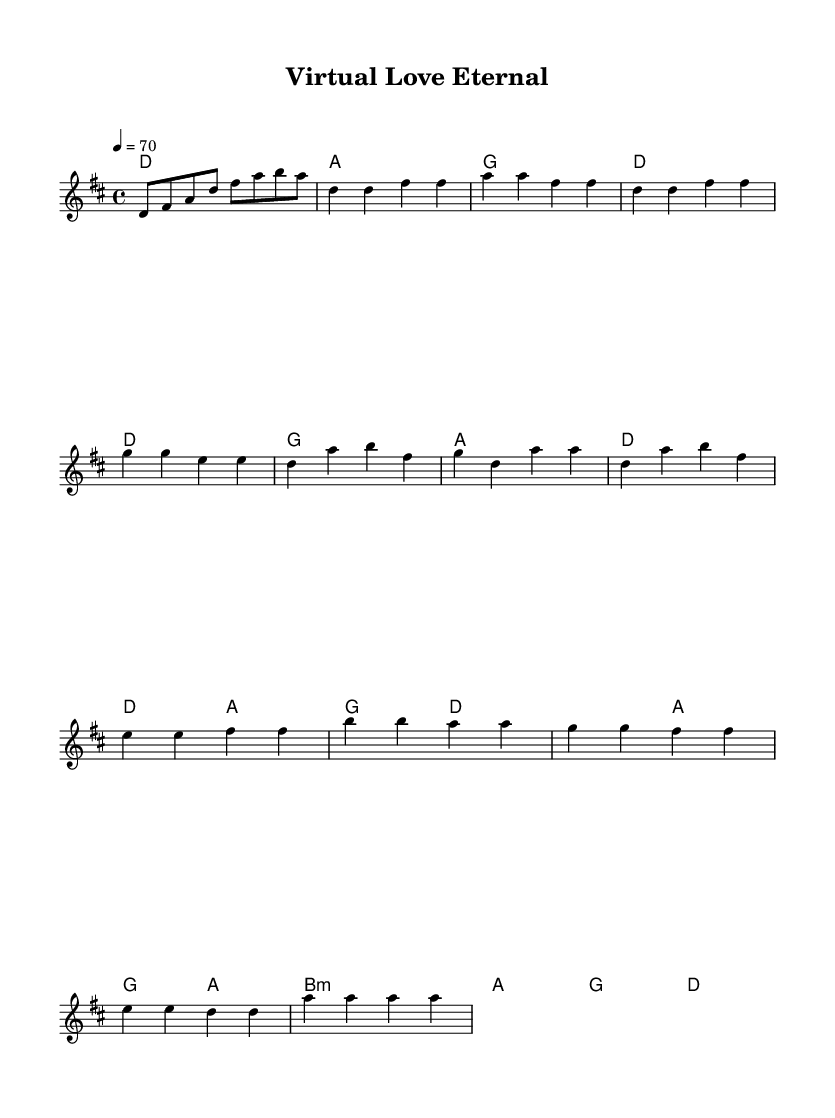What is the key signature of this music? The key signature is D major, which contains two sharps: F# and C#.
Answer: D major What is the time signature of this music? The time signature is 4/4, indicating four beats per measure.
Answer: 4/4 What is the tempo marking of this music? The tempo marking indicates a speed of 70 beats per minute, described as "Moderato."
Answer: 70 How many measures are in the chorus section? By counting the measures in the chorus part, we find that it consists of four measures.
Answer: 4 What is the chord for the bridge section's first measure? The first measure of the bridge section indicates a B minor chord.
Answer: B minor How does the verse section start musically? The verse section starts with a D note, followed by another D note in the second measure.
Answer: D What is the last note in the melody? The last note in the melody appears to be A in the bridge, reaffirming the theme before concluding.
Answer: A 